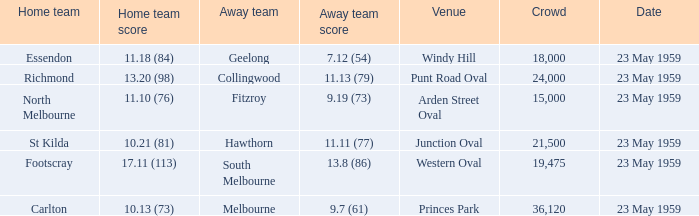What was the home team's score at the game that had a crowd larger than 24,000? 10.13 (73). 